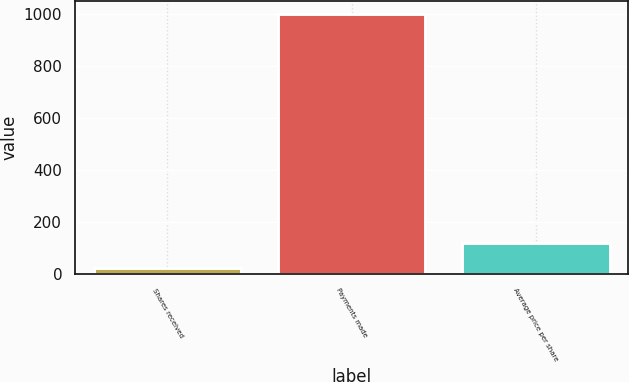<chart> <loc_0><loc_0><loc_500><loc_500><bar_chart><fcel>Shares received<fcel>Payments made<fcel>Average price per share<nl><fcel>21.9<fcel>1000<fcel>119.71<nl></chart> 